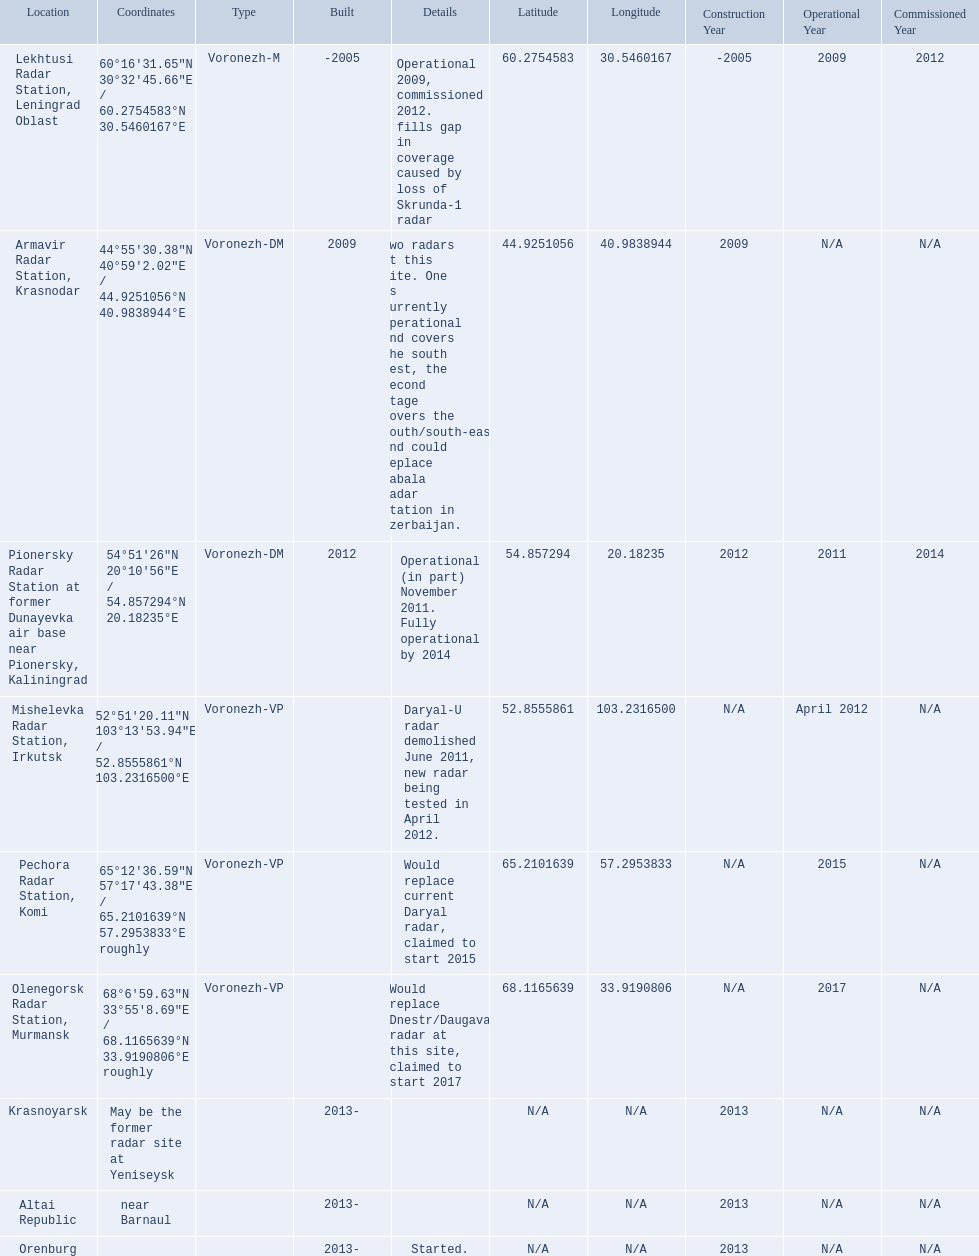Which column has the coordinates starting with 60 deg? 60°16′31.65″N 30°32′45.66″E﻿ / ﻿60.2754583°N 30.5460167°E. Write the full table. {'header': ['Location', 'Coordinates', 'Type', 'Built', 'Details', 'Latitude', 'Longitude', 'Construction Year', 'Operational Year', 'Commissioned Year'], 'rows': [['Lekhtusi Radar Station, Leningrad Oblast', '60°16′31.65″N 30°32′45.66″E\ufeff / \ufeff60.2754583°N 30.5460167°E', 'Voronezh-M', '-2005', 'Operational 2009, commissioned 2012. fills gap in coverage caused by loss of Skrunda-1 radar', '60.2754583', '30.5460167', '-2005', '2009', '2012'], ['Armavir Radar Station, Krasnodar', '44°55′30.38″N 40°59′2.02″E\ufeff / \ufeff44.9251056°N 40.9838944°E', 'Voronezh-DM', '2009', 'Two radars at this site. One is currently operational and covers the south west, the second stage covers the south/south-east and could replace Gabala Radar Station in Azerbaijan.', '44.9251056', '40.9838944', '2009', 'N/A', 'N/A'], ['Pionersky Radar Station at former Dunayevka air base near Pionersky, Kaliningrad', '54°51′26″N 20°10′56″E\ufeff / \ufeff54.857294°N 20.18235°E', 'Voronezh-DM', '2012', 'Operational (in part) November 2011. Fully operational by 2014', '54.857294', '20.18235', '2012', '2011', '2014'], ['Mishelevka Radar Station, Irkutsk', '52°51′20.11″N 103°13′53.94″E\ufeff / \ufeff52.8555861°N 103.2316500°E', 'Voronezh-VP', '', 'Daryal-U radar demolished June 2011, new radar being tested in April 2012.', '52.8555861', '103.2316500', 'N/A', 'April 2012', 'N/A'], ['Pechora Radar Station, Komi', '65°12′36.59″N 57°17′43.38″E\ufeff / \ufeff65.2101639°N 57.2953833°E roughly', 'Voronezh-VP', '', 'Would replace current Daryal radar, claimed to start 2015', '65.2101639', '57.2953833', 'N/A', '2015', 'N/A'], ['Olenegorsk Radar Station, Murmansk', '68°6′59.63″N 33°55′8.69″E\ufeff / \ufeff68.1165639°N 33.9190806°E roughly', 'Voronezh-VP', '', 'Would replace Dnestr/Daugava radar at this site, claimed to start 2017', '68.1165639', '33.9190806', 'N/A', '2017', 'N/A'], ['Krasnoyarsk', 'May be the former radar site at Yeniseysk', '', '2013-', '', 'N/A', 'N/A', '2013', 'N/A', 'N/A'], ['Altai Republic', 'near Barnaul', '', '2013-', '', 'N/A', 'N/A', '2013', 'N/A', 'N/A'], ['Orenburg', '', '', '2013-', 'Started.', 'N/A', 'N/A', '2013', 'N/A', 'N/A']]} What is the location in the same row as that column? Lekhtusi Radar Station, Leningrad Oblast. 